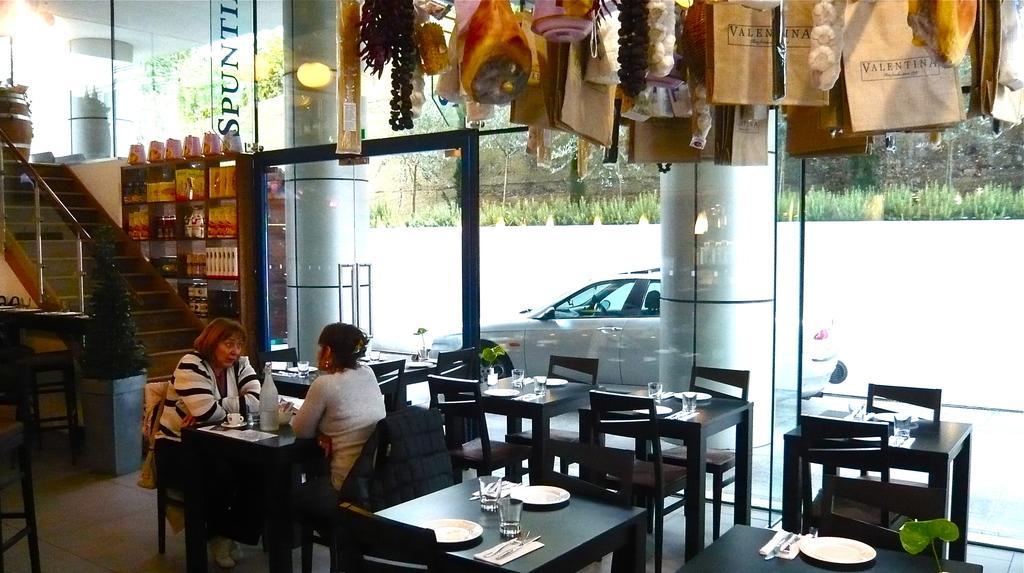How would you summarize this image in a sentence or two? In this image we can see two women are sitting on the chairs near table. We can see cups, bottles, glasses, plates, forks and knife on the tables. In the background we can see stairs, plant, cupboards, glass door and car. 